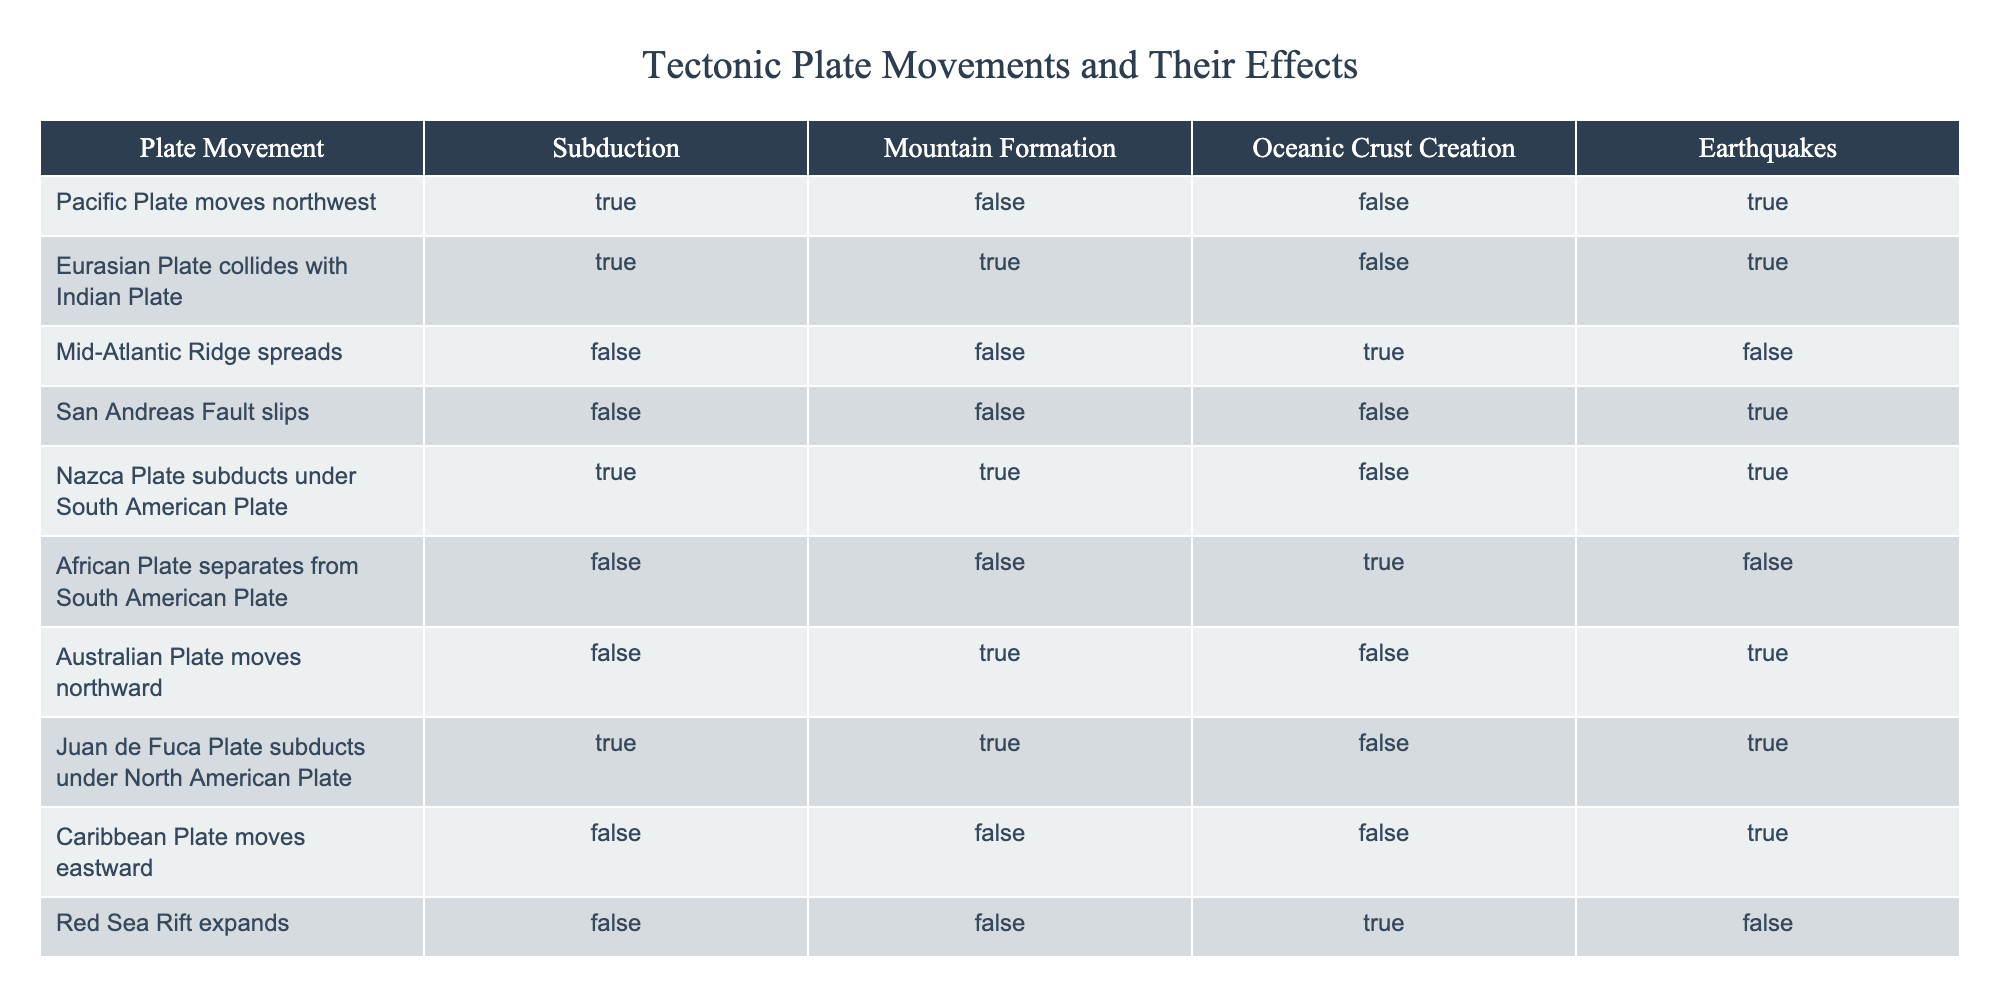What tectonic plate movement is associated with mountain formation? The table shows that the Eurasian Plate colliding with the Indian Plate and the Australian Plate moving northward both result in mountain formation. Therefore, movements that are linked to mountain formation are those two.
Answer: Eurasian Plate collides with Indian Plate, Australian Plate moves northward Did the Mid-Atlantic Ridge spreading result in earthquakes? Referring to the table, the Mid-Atlantic Ridge spreading does not produce earthquakes, as indicated by the FALSE value in the Earthquakes column for that specific movement.
Answer: No How many events lead to oceanic crust creation? From the table, oceanic crust creation occurs in two scenarios: the Mid-Atlantic Ridge spreading and the African Plate separating from the South American Plate. Adding these, we find there are two events that create oceanic crust.
Answer: 2 Which plate movements result in both subduction and earthquakes? Looking at the table, there are three movements that result in both subduction and earthquakes: the Pacific Plate moving northwest, the Nazca Plate subducting under the South American Plate, and the Juan de Fuca Plate subducting under the North American Plate.
Answer: 3 Is it true that all plate movements that result in mountain formation also cause earthquakes? The table indicates that the Eurasian Plate colliding with the Indian Plate results in both mountain formation and earthquakes, while the Australian Plate moving northward leads to mountain formation but not earthquakes. Hence, it is false that all such movements are associated with earthquakes.
Answer: No 